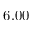<formula> <loc_0><loc_0><loc_500><loc_500>6 . 0 0</formula> 